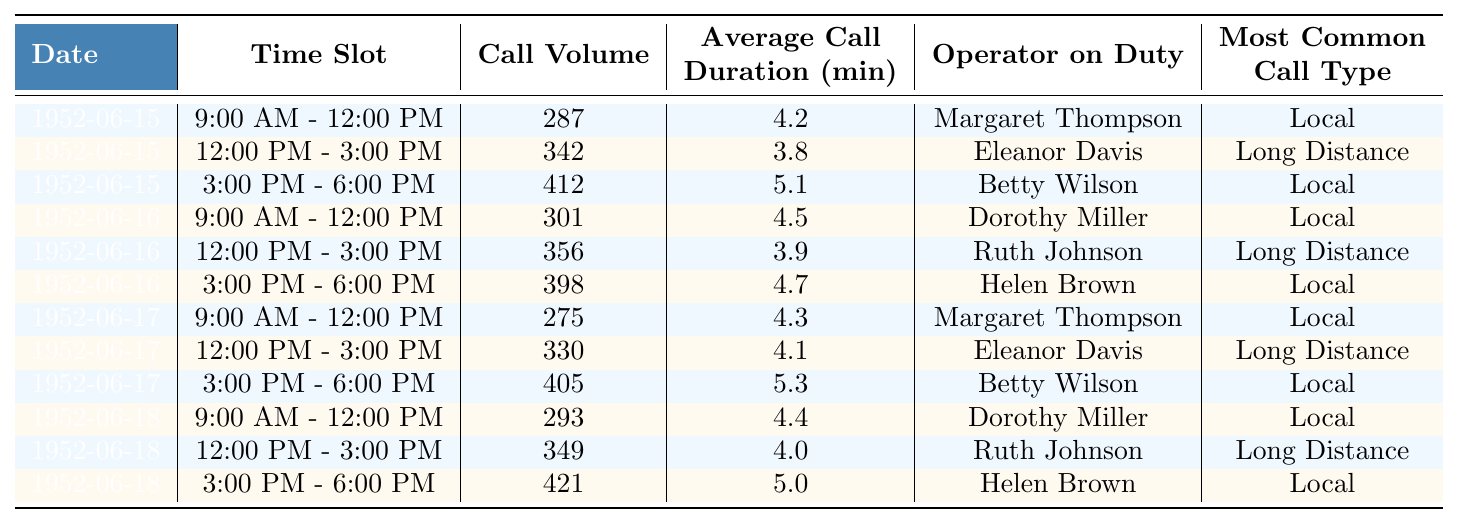What was the highest call volume recorded on June 15, 1952? Reviewing the data for June 15, 1952, the call volumes during the time slots were 287, 342, and 412. The highest value among these is 412.
Answer: 412 Who was the operator on duty during the 12:00 PM to 3:00 PM time slot on June 16, 1952? Looking at the data for June 16, 1952, in the 12:00 PM to 3:00 PM time slot, the operator on duty was Ruth Johnson.
Answer: Ruth Johnson What is the average call duration for all the time slots on June 18, 1952? The average call durations for June 18, 1952, are 4.4, 4.0, and 5.0 minutes. To find the average, sum these values (4.4 + 4.0 + 5.0 = 13.4) and divide by the number of slots (13.4 / 3 ≈ 4.47).
Answer: 4.47 minutes Did Betty Wilson work the same number of time slots across different days? Checking the data, Betty Wilson worked two time slots on June 15 (morning and afternoon) and one time slot on June 17 (afternoon). Thus, she did not work the same number of time slots on different days.
Answer: No What was the total call volume for the 9:00 AM to 12:00 PM time slots over the four days recorded? The call volumes for this time slot on the recorded days are: June 15 (287), June 16 (301), June 17 (275), and June 18 (293). Adding these values gives (287 + 301 + 275 + 293 = 1156).
Answer: 1156 Was the most common call type for the afternoon of June 17, 1952, a local call? For June 17, 1952, in the 12:00 PM to 3:00 PM slot, the most common call type was Long Distance. Therefore, it wasn't a local call.
Answer: No Which operator had the highest average call duration in their shifts? The average call durations for each operator are: Margaret Thompson (4.25), Eleanor Davis (4.1), Betty Wilson (5.2), Dorothy Miller (4.45), Ruth Johnson (4.3), and Helen Brown (5.05). The highest average is held by Betty Wilson with 5.2.
Answer: Betty Wilson Were local calls more frequent than long-distance calls across all recorded time slots? By counting each time slot, we find that local calls occurred 7 times, while long-distance calls occurred 5 times, indicating local calls were indeed more frequent.
Answer: Yes 